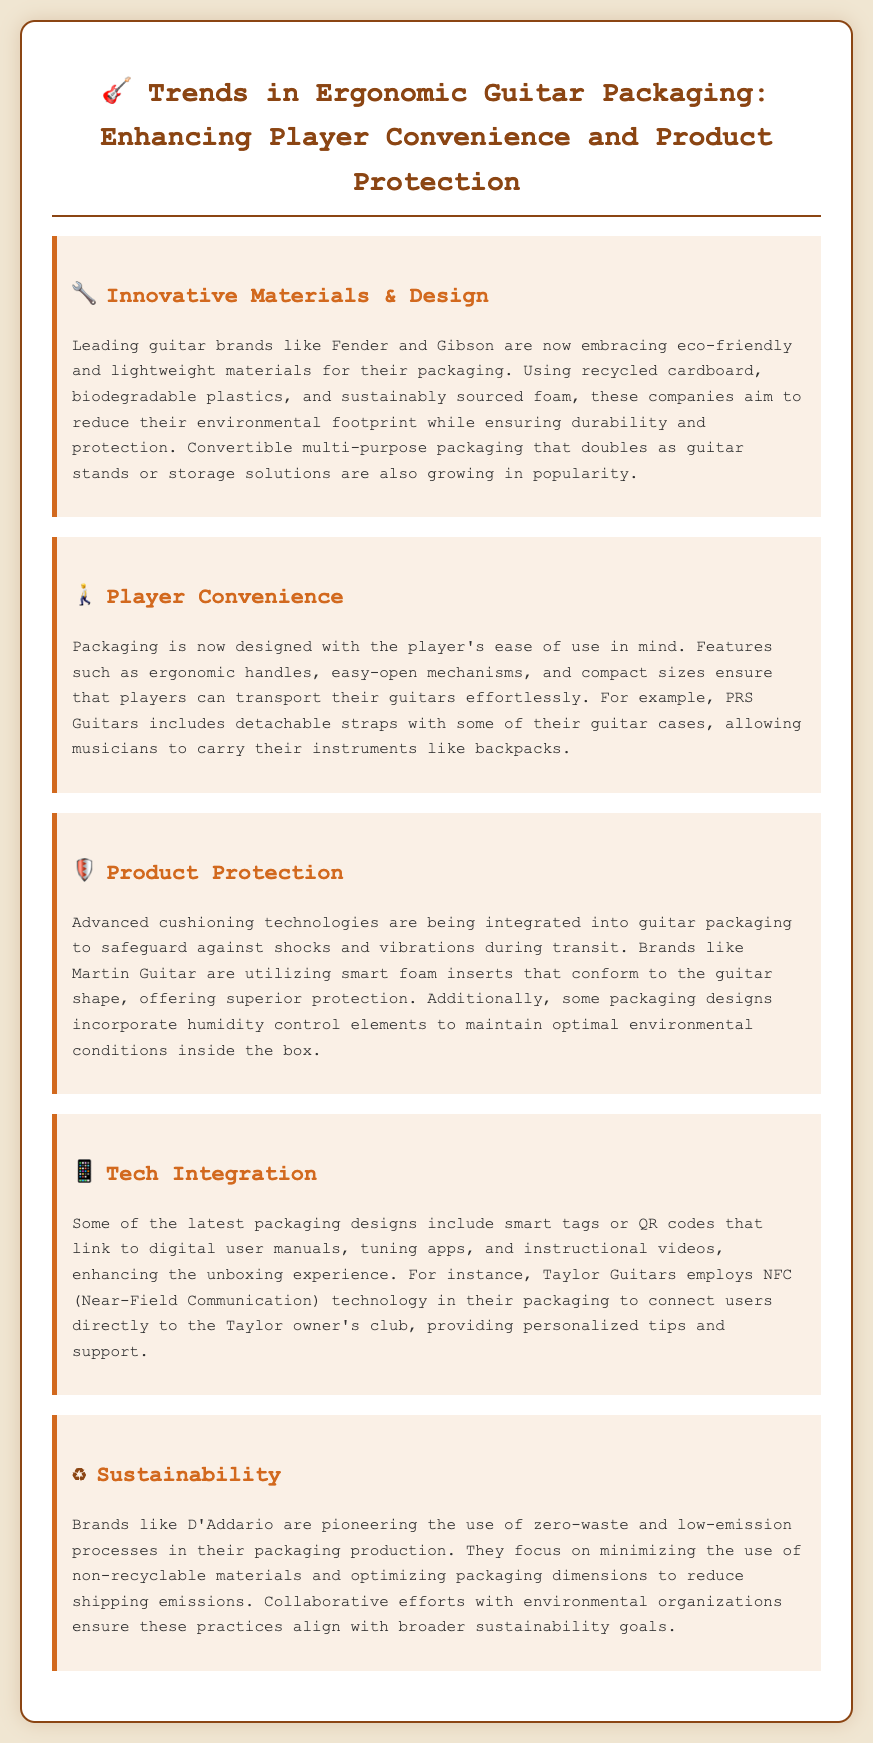What are the eco-friendly materials used in guitar packaging? The document mentions recycled cardboard, biodegradable plastics, and sustainably sourced foam as eco-friendly materials in guitar packaging.
Answer: Recycled cardboard, biodegradable plastics, and sustainably sourced foam Which company includes detachable straps with their guitar cases? The document states that PRS Guitars includes detachable straps with some of their guitar cases.
Answer: PRS Guitars What advanced technology does Martin Guitar use for protection? The document indicates that Martin Guitar utilizes smart foam inserts that conform to the guitar shape for protection.
Answer: Smart foam inserts Which packaging feature enhances the unboxing experience according to the document? The document describes smart tags or QR codes that link to digital user manuals and apps as features enhancing the unboxing experience.
Answer: Smart tags or QR codes What focus does D'Addario have in their packaging processes? The document highlights that D'Addario focuses on zero-waste and low-emission processes in their packaging production.
Answer: Zero-waste and low-emission processes What ergonomic feature does the document mention to improve player convenience? The document mentions ergonomic handles as a feature to improve player convenience in guitar packaging.
Answer: Ergonomic handles Which brand is mentioned for pioneering sustainability efforts? The document states that D'Addario is pioneering the use of zero-waste and low-emission processes in their packaging.
Answer: D'Addario How does Taylor Guitars utilize technology in their packaging? The document explains that Taylor Guitars employs NFC technology in their packaging to connect users to their owner's club.
Answer: NFC technology 